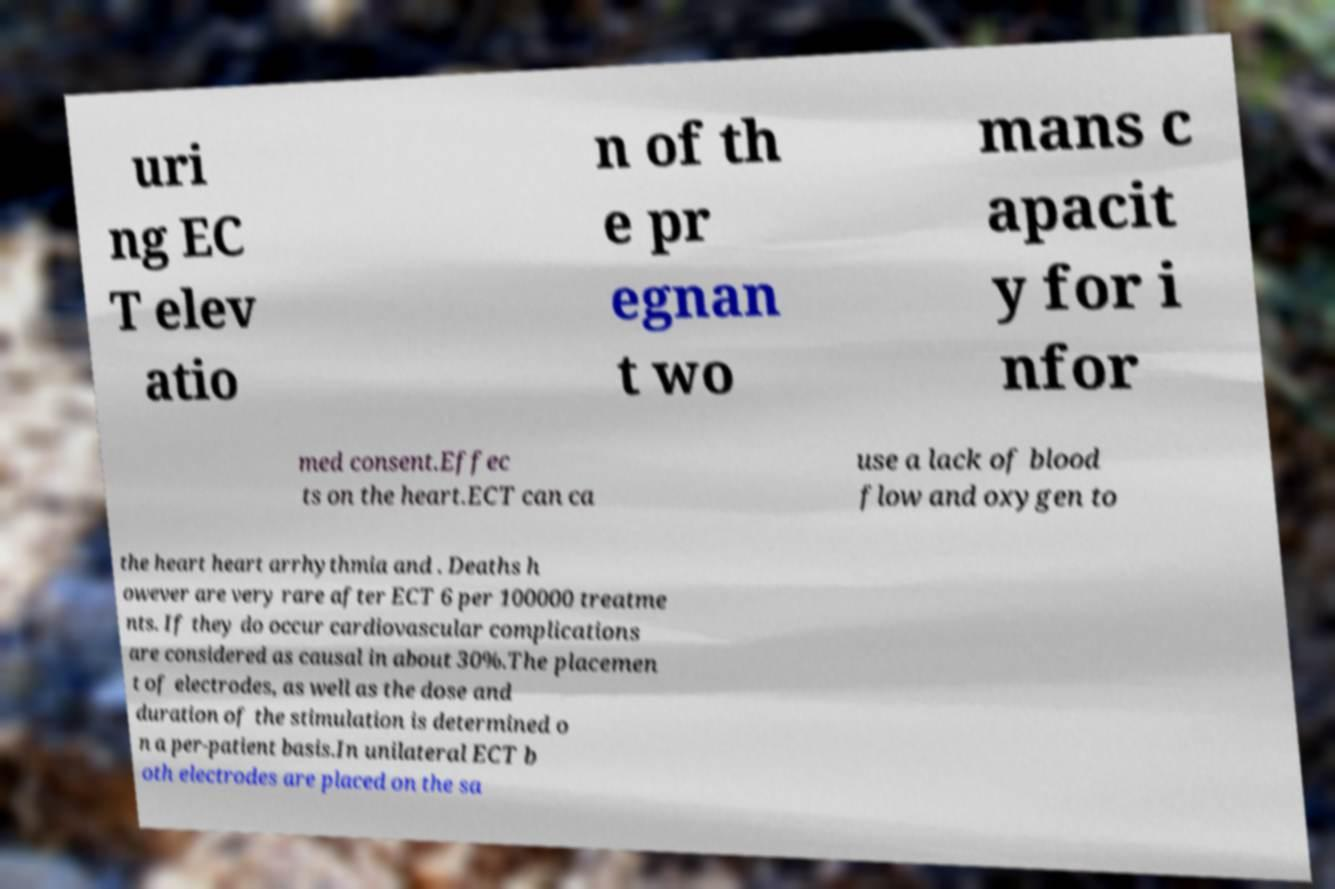For documentation purposes, I need the text within this image transcribed. Could you provide that? uri ng EC T elev atio n of th e pr egnan t wo mans c apacit y for i nfor med consent.Effec ts on the heart.ECT can ca use a lack of blood flow and oxygen to the heart heart arrhythmia and . Deaths h owever are very rare after ECT 6 per 100000 treatme nts. If they do occur cardiovascular complications are considered as causal in about 30%.The placemen t of electrodes, as well as the dose and duration of the stimulation is determined o n a per-patient basis.In unilateral ECT b oth electrodes are placed on the sa 